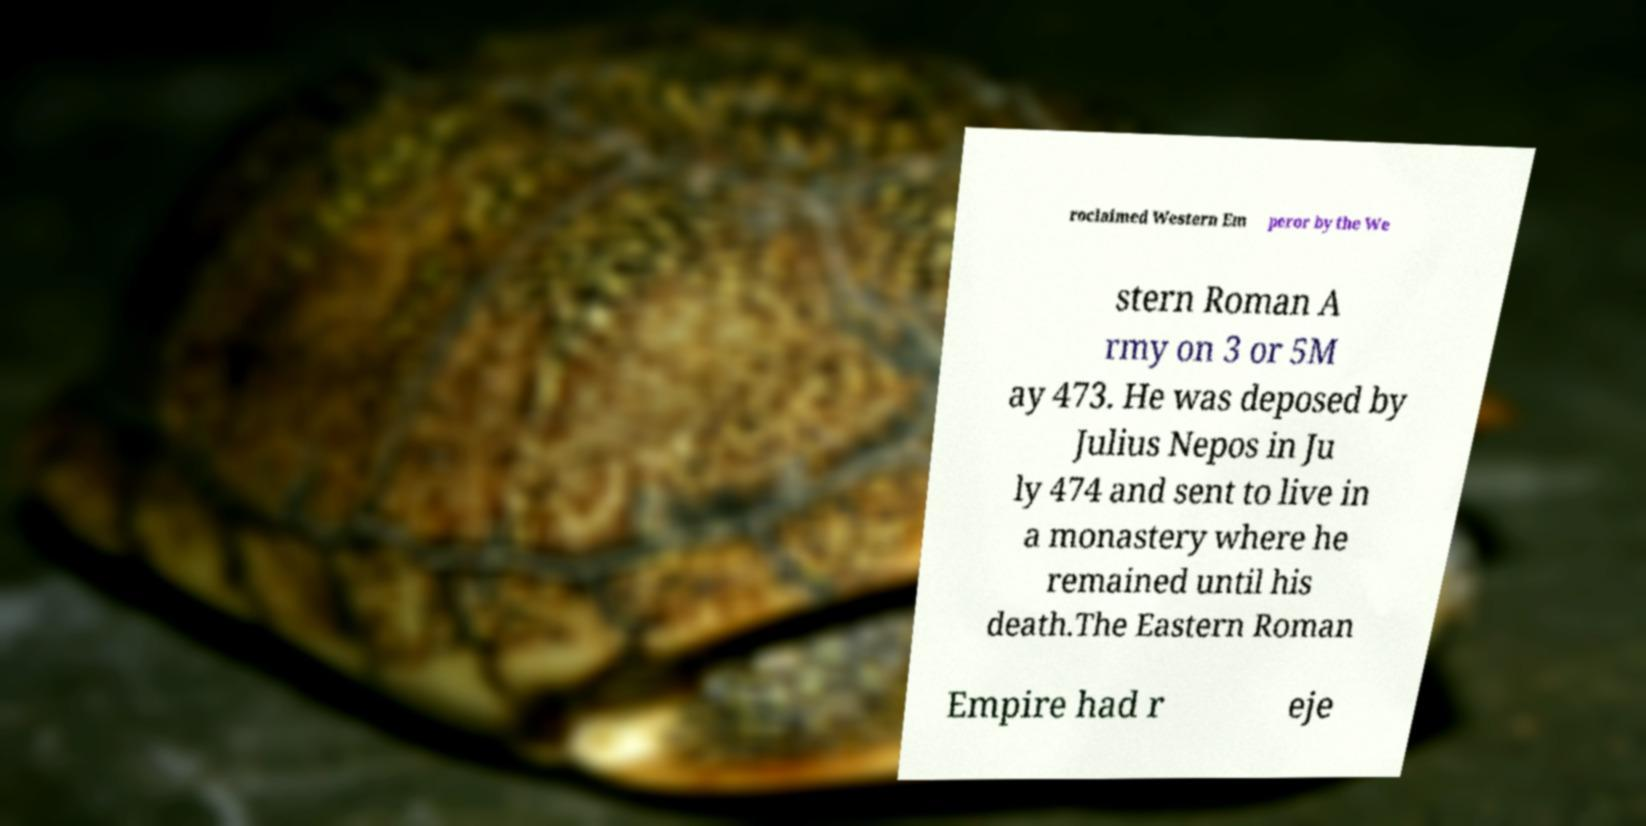Please identify and transcribe the text found in this image. roclaimed Western Em peror by the We stern Roman A rmy on 3 or 5M ay 473. He was deposed by Julius Nepos in Ju ly 474 and sent to live in a monastery where he remained until his death.The Eastern Roman Empire had r eje 